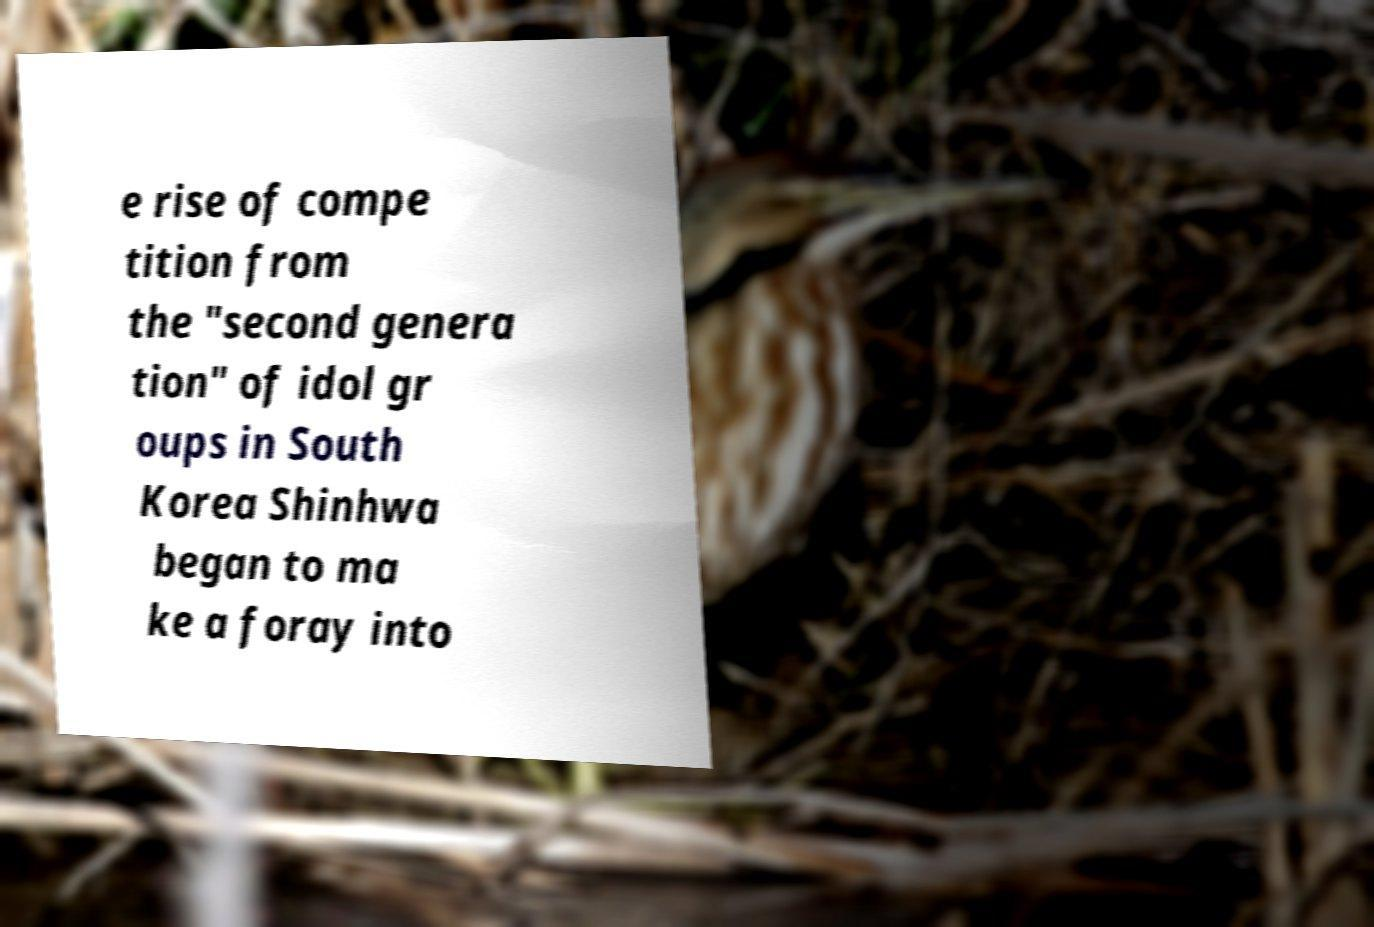What messages or text are displayed in this image? I need them in a readable, typed format. e rise of compe tition from the "second genera tion" of idol gr oups in South Korea Shinhwa began to ma ke a foray into 